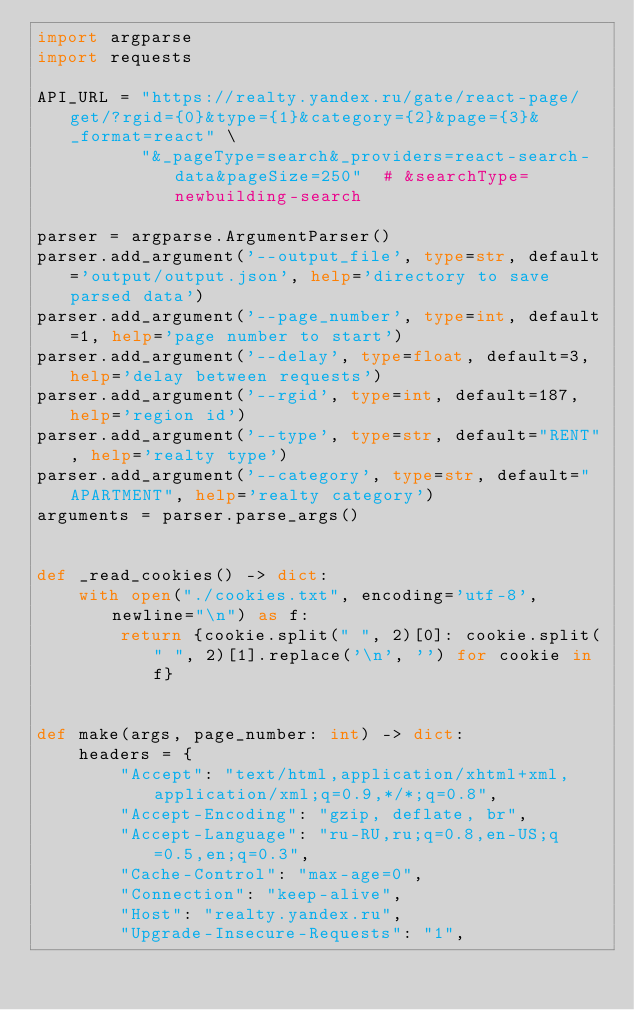<code> <loc_0><loc_0><loc_500><loc_500><_Python_>import argparse
import requests

API_URL = "https://realty.yandex.ru/gate/react-page/get/?rgid={0}&type={1}&category={2}&page={3}&_format=react" \
          "&_pageType=search&_providers=react-search-data&pageSize=250"  # &searchType=newbuilding-search

parser = argparse.ArgumentParser()
parser.add_argument('--output_file', type=str, default='output/output.json', help='directory to save parsed data')
parser.add_argument('--page_number', type=int, default=1, help='page number to start')
parser.add_argument('--delay', type=float, default=3, help='delay between requests')
parser.add_argument('--rgid', type=int, default=187, help='region id')
parser.add_argument('--type', type=str, default="RENT", help='realty type')
parser.add_argument('--category', type=str, default="APARTMENT", help='realty category')
arguments = parser.parse_args()


def _read_cookies() -> dict:
    with open("./cookies.txt", encoding='utf-8', newline="\n") as f:
        return {cookie.split(" ", 2)[0]: cookie.split(" ", 2)[1].replace('\n', '') for cookie in f}


def make(args, page_number: int) -> dict:
    headers = {
        "Accept": "text/html,application/xhtml+xml,application/xml;q=0.9,*/*;q=0.8",
        "Accept-Encoding": "gzip, deflate, br",
        "Accept-Language": "ru-RU,ru;q=0.8,en-US;q=0.5,en;q=0.3",
        "Cache-Control": "max-age=0",
        "Connection": "keep-alive",
        "Host": "realty.yandex.ru",
        "Upgrade-Insecure-Requests": "1",</code> 